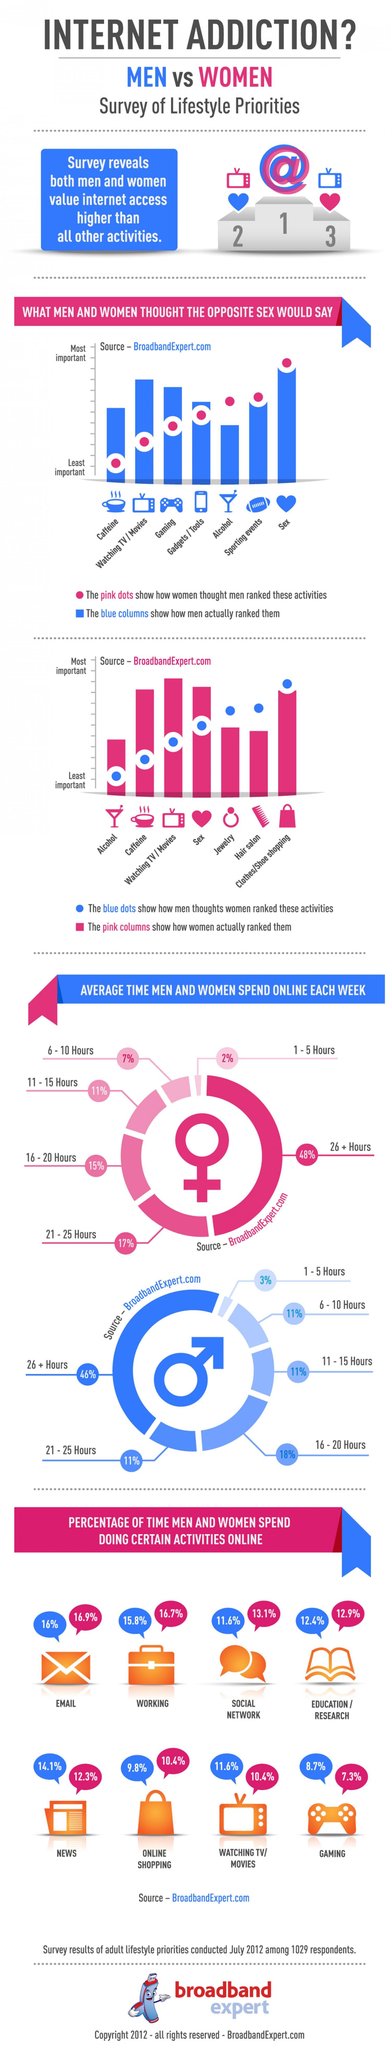List a handful of essential elements in this visual. Women ranked alcohol very highly, but it was the lowest priority when men ranked it. According to a female survey, jewelry is considered a higher priority than activities such as alcohol and visits to the hair salon. According to the given information, both males and females spend more than 15% of their time on online activities such as email and working. According to a recent survey, men have ranked clothes and shoe shopping as the most important activity for women. Gaming is the online activity that is the least popular for both males and females. 